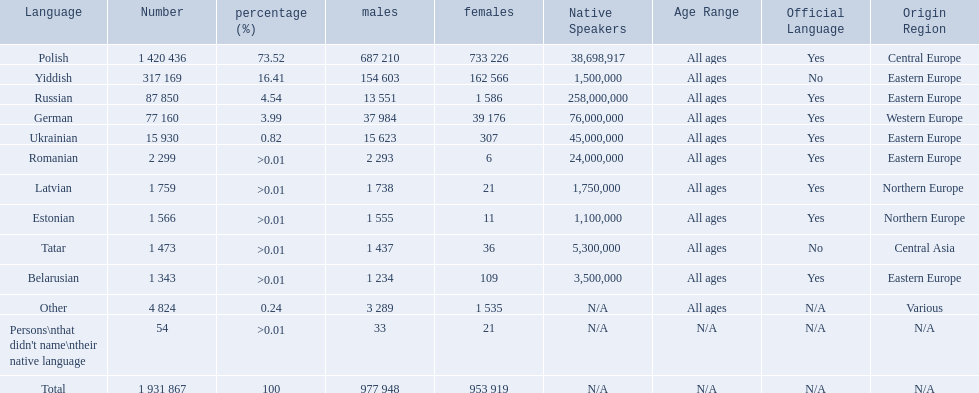What were all the languages? Polish, Yiddish, Russian, German, Ukrainian, Romanian, Latvian, Estonian, Tatar, Belarusian, Other, Persons\nthat didn't name\ntheir native language. For these, how many people spoke them? 1 420 436, 317 169, 87 850, 77 160, 15 930, 2 299, 1 759, 1 566, 1 473, 1 343, 4 824, 54. Of these, which is the largest number of speakers? 1 420 436. Which language corresponds to this number? Polish. 